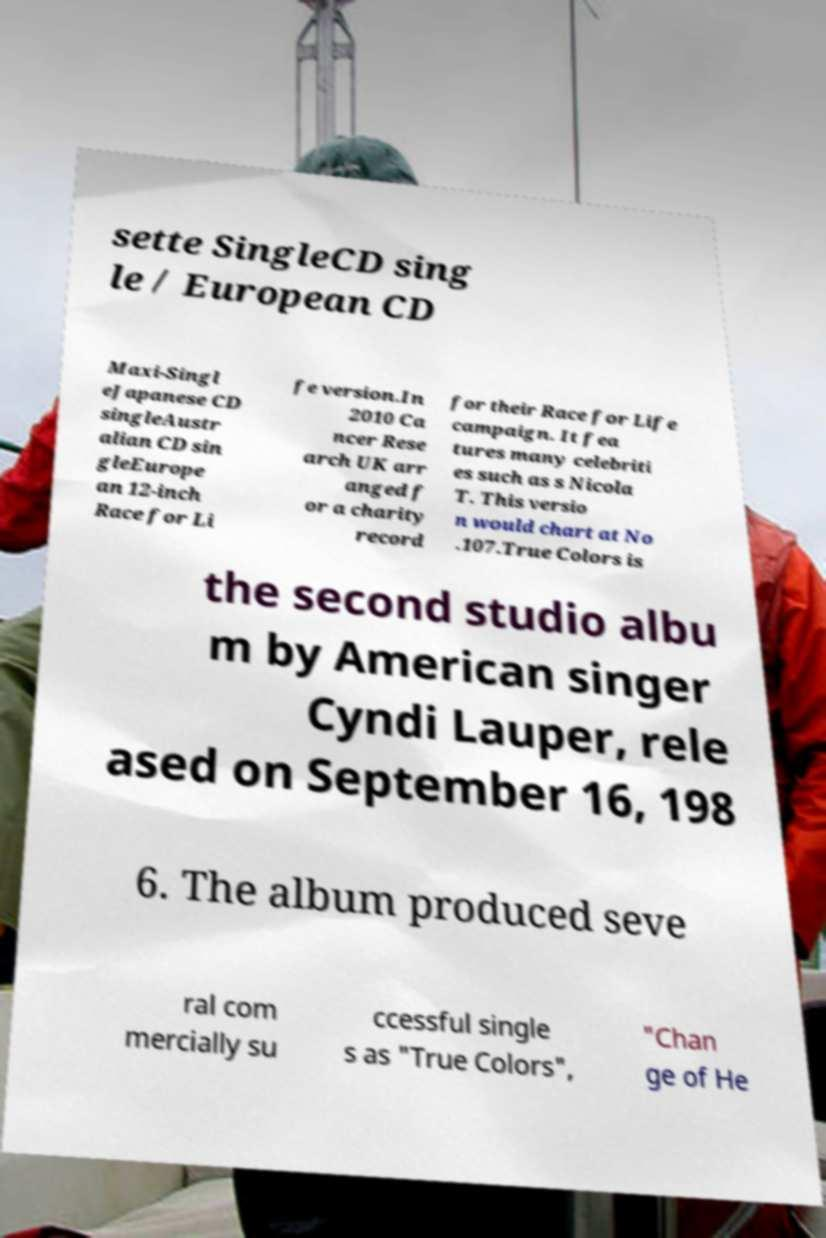Please identify and transcribe the text found in this image. sette SingleCD sing le / European CD Maxi-Singl eJapanese CD singleAustr alian CD sin gleEurope an 12-inch Race for Li fe version.In 2010 Ca ncer Rese arch UK arr anged f or a charity record for their Race for Life campaign. It fea tures many celebriti es such as s Nicola T. This versio n would chart at No .107.True Colors is the second studio albu m by American singer Cyndi Lauper, rele ased on September 16, 198 6. The album produced seve ral com mercially su ccessful single s as "True Colors", "Chan ge of He 